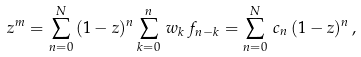Convert formula to latex. <formula><loc_0><loc_0><loc_500><loc_500>z ^ { m } = \sum ^ { N } _ { n = 0 } \, ( 1 - z ) ^ { n } \sum ^ { n } _ { k = 0 } \, w _ { k } \, f _ { n - k } = \sum ^ { N } _ { n = 0 } \, c _ { n } \, ( 1 - z ) ^ { n } \, ,</formula> 